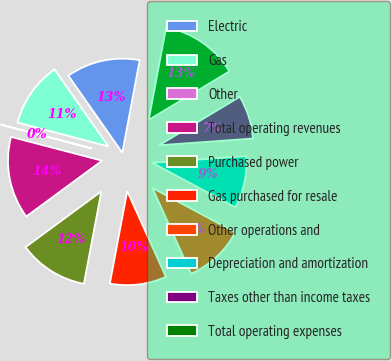<chart> <loc_0><loc_0><loc_500><loc_500><pie_chart><fcel>Electric<fcel>Gas<fcel>Other<fcel>Total operating revenues<fcel>Purchased power<fcel>Gas purchased for resale<fcel>Other operations and<fcel>Depreciation and amortization<fcel>Taxes other than income taxes<fcel>Total operating expenses<nl><fcel>12.68%<fcel>11.19%<fcel>0.02%<fcel>14.17%<fcel>11.94%<fcel>9.7%<fcel>10.45%<fcel>8.96%<fcel>7.47%<fcel>13.43%<nl></chart> 